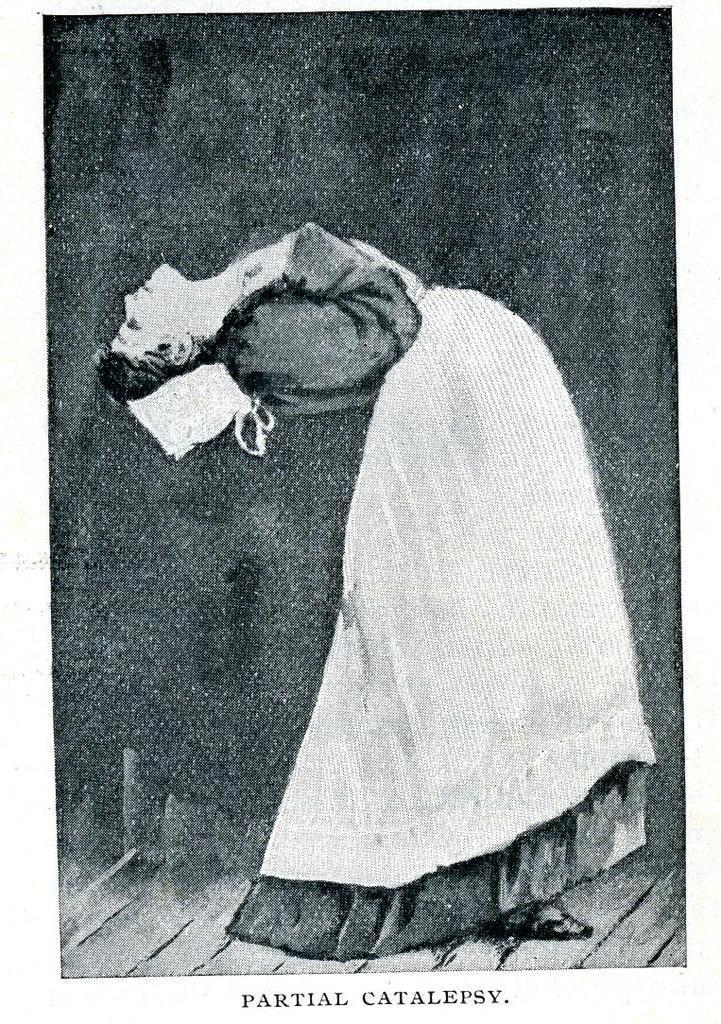In one or two sentences, can you explain what this image depicts? It looks like an old picture. We can see a woman on the path and it is written something on it. 